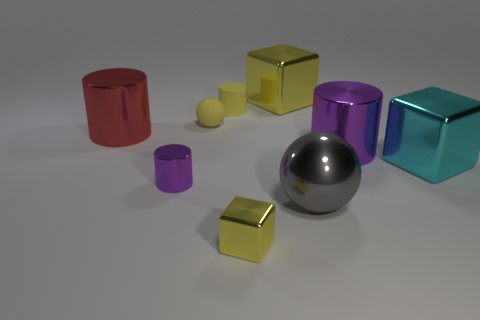There is a yellow thing that is both behind the tiny ball and right of the yellow matte cylinder; what is its shape?
Your answer should be compact. Cube. Is the number of shiny cubes greater than the number of cylinders?
Ensure brevity in your answer.  No. What material is the large yellow object?
Your answer should be compact. Metal. Is there any other thing that is the same size as the gray metallic sphere?
Offer a terse response. Yes. There is a matte thing that is the same shape as the gray metallic object; what is its size?
Offer a terse response. Small. There is a large shiny object behind the big red metal object; is there a cyan block that is behind it?
Make the answer very short. No. Is the color of the tiny matte cylinder the same as the tiny sphere?
Offer a very short reply. Yes. How many other objects are the same shape as the large gray object?
Offer a terse response. 1. Are there more big gray things behind the tiny shiny cylinder than big cylinders that are to the left of the big yellow object?
Your answer should be compact. No. Does the yellow shiny block that is in front of the yellow sphere have the same size as the purple object that is right of the tiny yellow metal block?
Your answer should be compact. No. 